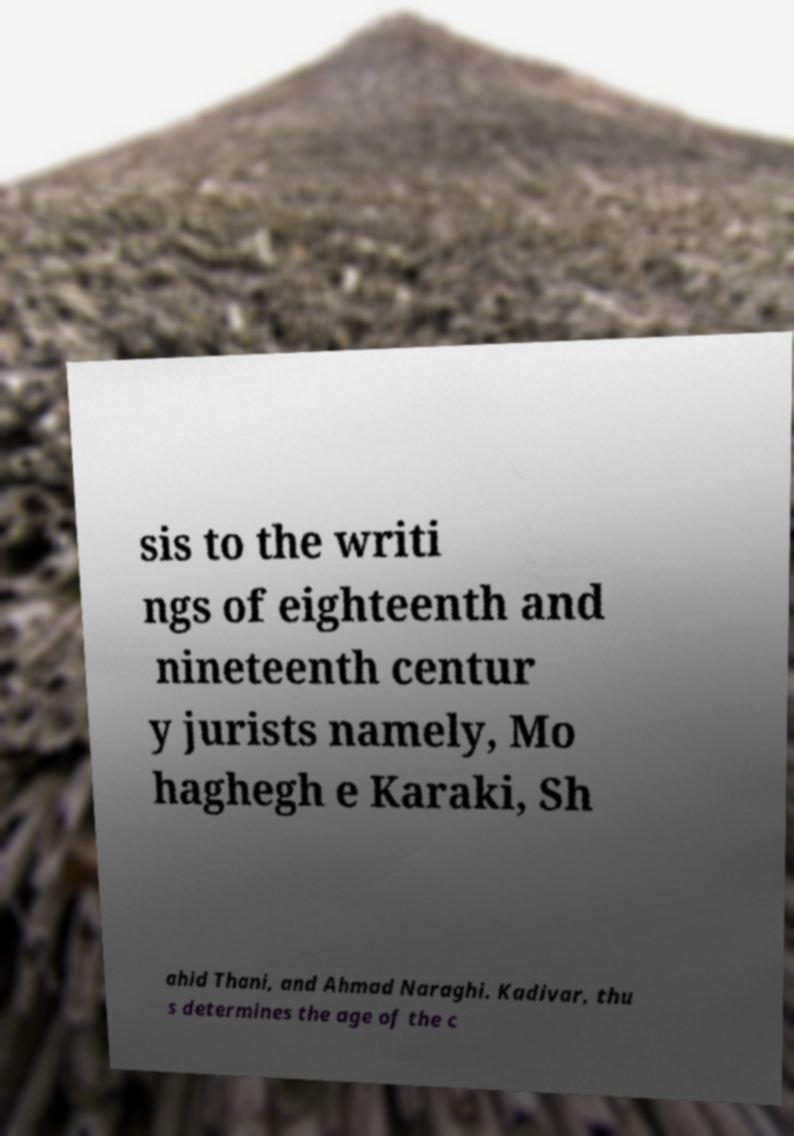For documentation purposes, I need the text within this image transcribed. Could you provide that? sis to the writi ngs of eighteenth and nineteenth centur y jurists namely, Mo haghegh e Karaki, Sh ahid Thani, and Ahmad Naraghi. Kadivar, thu s determines the age of the c 